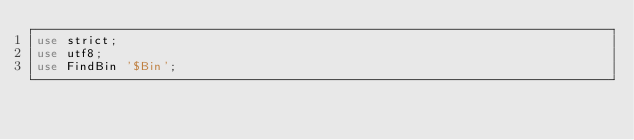Convert code to text. <code><loc_0><loc_0><loc_500><loc_500><_Perl_>use strict;
use utf8;
use FindBin '$Bin';
</code> 